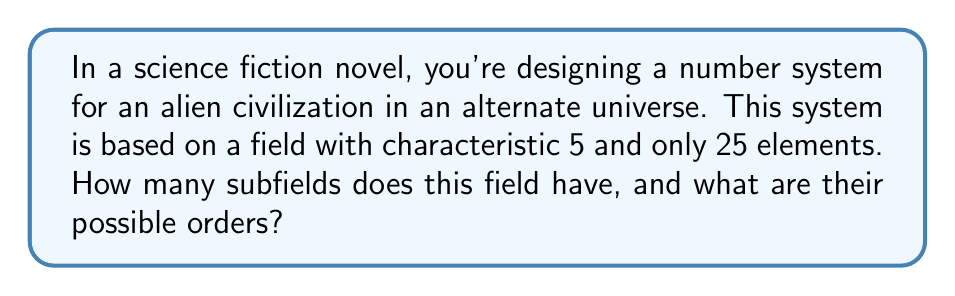Help me with this question. To solve this problem, we need to apply concepts from field theory:

1) First, we recognize that the field described is $\mathbb{F}_{25}$, the finite field with 25 elements.

2) The characteristic of a field is the smallest positive integer $n$ such that $n \cdot 1 = 0$ in the field. Here, it's given as 5.

3) In a finite field, the number of elements must be a power of its characteristic. So, $25 = 5^2$.

4) The subfields of $\mathbb{F}_{25}$ must have orders that divide 25. The divisors of 25 are 1, 5, and 25.

5) However, 1 is not a valid order for a field. So, we're left with potential subfields of orders 5 and 25.

6) $\mathbb{F}_{25}$ always contains $\mathbb{F}_5$ as a subfield (the prime subfield).

7) $\mathbb{F}_{25}$ is also a subfield of itself (the improper subfield).

Therefore, $\mathbb{F}_{25}$ has exactly two subfields: $\mathbb{F}_5$ and $\mathbb{F}_{25}$ itself.

This alien number system, despite having 25 elements, maintains a relatively simple subfield structure, which could be an interesting plot point in a sci-fi novel about mathematical discoveries in alternate universes.
Answer: The field $\mathbb{F}_{25}$ has 2 subfields, with orders 5 and 25. 